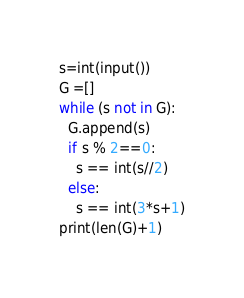<code> <loc_0><loc_0><loc_500><loc_500><_Python_>s=int(input())
G =[]
while (s not in G):
  G.append(s)
  if s % 2==0:
    s == int(s//2)
  else:
    s == int(3*s+1)
print(len(G)+1)</code> 